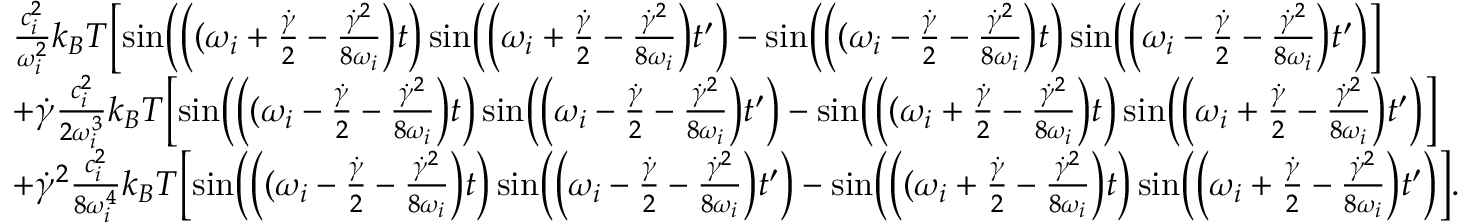<formula> <loc_0><loc_0><loc_500><loc_500>\begin{array} { r l } & { \frac { c _ { i } ^ { 2 } } { \omega _ { i } ^ { 2 } } k _ { B } T \left [ \sin \left ( \left ( ( \omega _ { i } + \frac { \dot { \gamma } } { 2 } - \frac { \dot { \gamma } ^ { 2 } } { 8 \omega _ { i } } \right ) t \right ) \sin \left ( \left ( \omega _ { i } + \frac { \dot { \gamma } } { 2 } - \frac { \dot { \gamma } ^ { 2 } } { 8 \omega _ { i } } \right ) t ^ { \prime } \right ) - \sin \left ( \left ( ( \omega _ { i } - \frac { \dot { \gamma } } { 2 } - \frac { \dot { \gamma } ^ { 2 } } { 8 \omega _ { i } } \right ) t \right ) \sin \left ( \left ( \omega _ { i } - \frac { \dot { \gamma } } { 2 } - \frac { \dot { \gamma } ^ { 2 } } { 8 \omega _ { i } } \right ) t ^ { \prime } \right ) \right ] } \\ & { + \dot { \gamma } \frac { c _ { i } ^ { 2 } } { 2 \omega _ { i } ^ { 3 } } k _ { B } T \left [ \sin \left ( \left ( ( \omega _ { i } - \frac { \dot { \gamma } } { 2 } - \frac { \dot { \gamma } ^ { 2 } } { 8 \omega _ { i } } \right ) t \right ) \sin \left ( \left ( \omega _ { i } - \frac { \dot { \gamma } } { 2 } - \frac { \dot { \gamma } ^ { 2 } } { 8 \omega _ { i } } \right ) t ^ { \prime } \right ) - \sin \left ( \left ( ( \omega _ { i } + \frac { \dot { \gamma } } { 2 } - \frac { \dot { \gamma } ^ { 2 } } { 8 \omega _ { i } } \right ) t \right ) \sin \left ( \left ( \omega _ { i } + \frac { \dot { \gamma } } { 2 } - \frac { \dot { \gamma } ^ { 2 } } { 8 \omega _ { i } } \right ) t ^ { \prime } \right ) \right ] } \\ & { + \dot { \gamma } ^ { 2 } \frac { c _ { i } ^ { 2 } } { 8 \omega _ { i } ^ { 4 } } k _ { B } T \left [ \sin \left ( \left ( ( \omega _ { i } - \frac { \dot { \gamma } } { 2 } - \frac { \dot { \gamma } ^ { 2 } } { 8 \omega _ { i } } \right ) t \right ) \sin \left ( \left ( \omega _ { i } - \frac { \dot { \gamma } } { 2 } - \frac { \dot { \gamma } ^ { 2 } } { 8 \omega _ { i } } \right ) t ^ { \prime } \right ) - \sin \left ( \left ( ( \omega _ { i } + \frac { \dot { \gamma } } { 2 } - \frac { \dot { \gamma } ^ { 2 } } { 8 \omega _ { i } } \right ) t \right ) \sin \left ( \left ( \omega _ { i } + \frac { \dot { \gamma } } { 2 } - \frac { \dot { \gamma } ^ { 2 } } { 8 \omega _ { i } } \right ) t ^ { \prime } \right ) \right ] . } \end{array}</formula> 